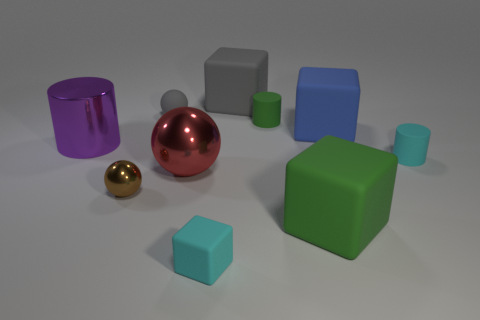Subtract all blue spheres. Subtract all cyan cylinders. How many spheres are left? 3 Subtract all cylinders. How many objects are left? 7 Subtract all large purple objects. Subtract all blue things. How many objects are left? 8 Add 3 green cylinders. How many green cylinders are left? 4 Add 8 small blocks. How many small blocks exist? 9 Subtract 0 gray cylinders. How many objects are left? 10 